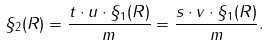<formula> <loc_0><loc_0><loc_500><loc_500>\S _ { 2 } ( R ) = \frac { t \cdot u \cdot \S _ { 1 } ( R ) } { m } = \frac { s \cdot v \cdot \S _ { 1 } ( R ) } { m } .</formula> 